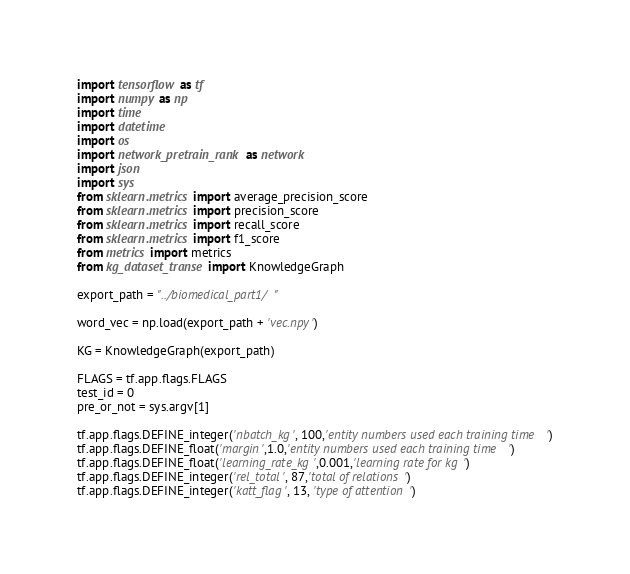Convert code to text. <code><loc_0><loc_0><loc_500><loc_500><_Python_>import tensorflow as tf
import numpy as np
import time
import datetime
import os
import network_pretrain_rank as network
import json
import sys
from sklearn.metrics import average_precision_score
from sklearn.metrics import precision_score
from sklearn.metrics import recall_score
from sklearn.metrics import f1_score
from metrics import metrics
from kg_dataset_transe import KnowledgeGraph

export_path = "../biomedical_part1/"

word_vec = np.load(export_path + 'vec.npy')

KG = KnowledgeGraph(export_path)

FLAGS = tf.app.flags.FLAGS
test_id = 0
pre_or_not = sys.argv[1]

tf.app.flags.DEFINE_integer('nbatch_kg', 100,'entity numbers used each training time')
tf.app.flags.DEFINE_float('margin',1.0,'entity numbers used each training time')
tf.app.flags.DEFINE_float('learning_rate_kg',0.001,'learning rate for kg')
tf.app.flags.DEFINE_integer('rel_total', 87,'total of relations')
tf.app.flags.DEFINE_integer('katt_flag', 13, 'type of attention')
</code> 